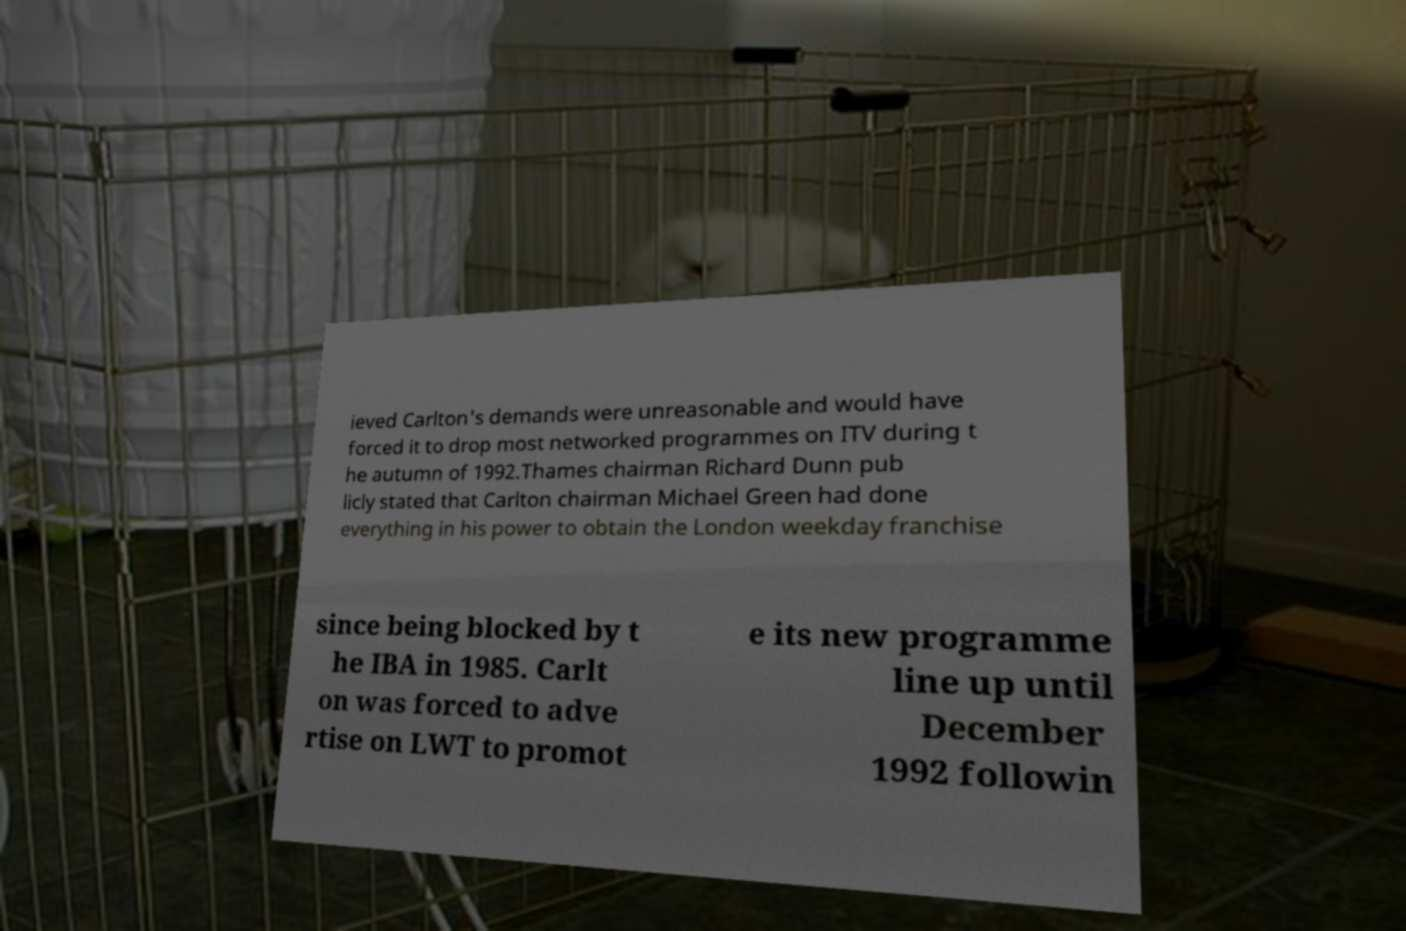Can you read and provide the text displayed in the image?This photo seems to have some interesting text. Can you extract and type it out for me? ieved Carlton's demands were unreasonable and would have forced it to drop most networked programmes on ITV during t he autumn of 1992.Thames chairman Richard Dunn pub licly stated that Carlton chairman Michael Green had done everything in his power to obtain the London weekday franchise since being blocked by t he IBA in 1985. Carlt on was forced to adve rtise on LWT to promot e its new programme line up until December 1992 followin 